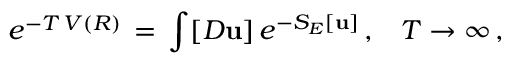Convert formula to latex. <formula><loc_0><loc_0><loc_500><loc_500>e ^ { - T \, V ( R ) } \, = \, \int [ D { u } ] \, e ^ { - S _ { E } [ { u } ] } \, { , } \quad T \to \infty \, { , }</formula> 